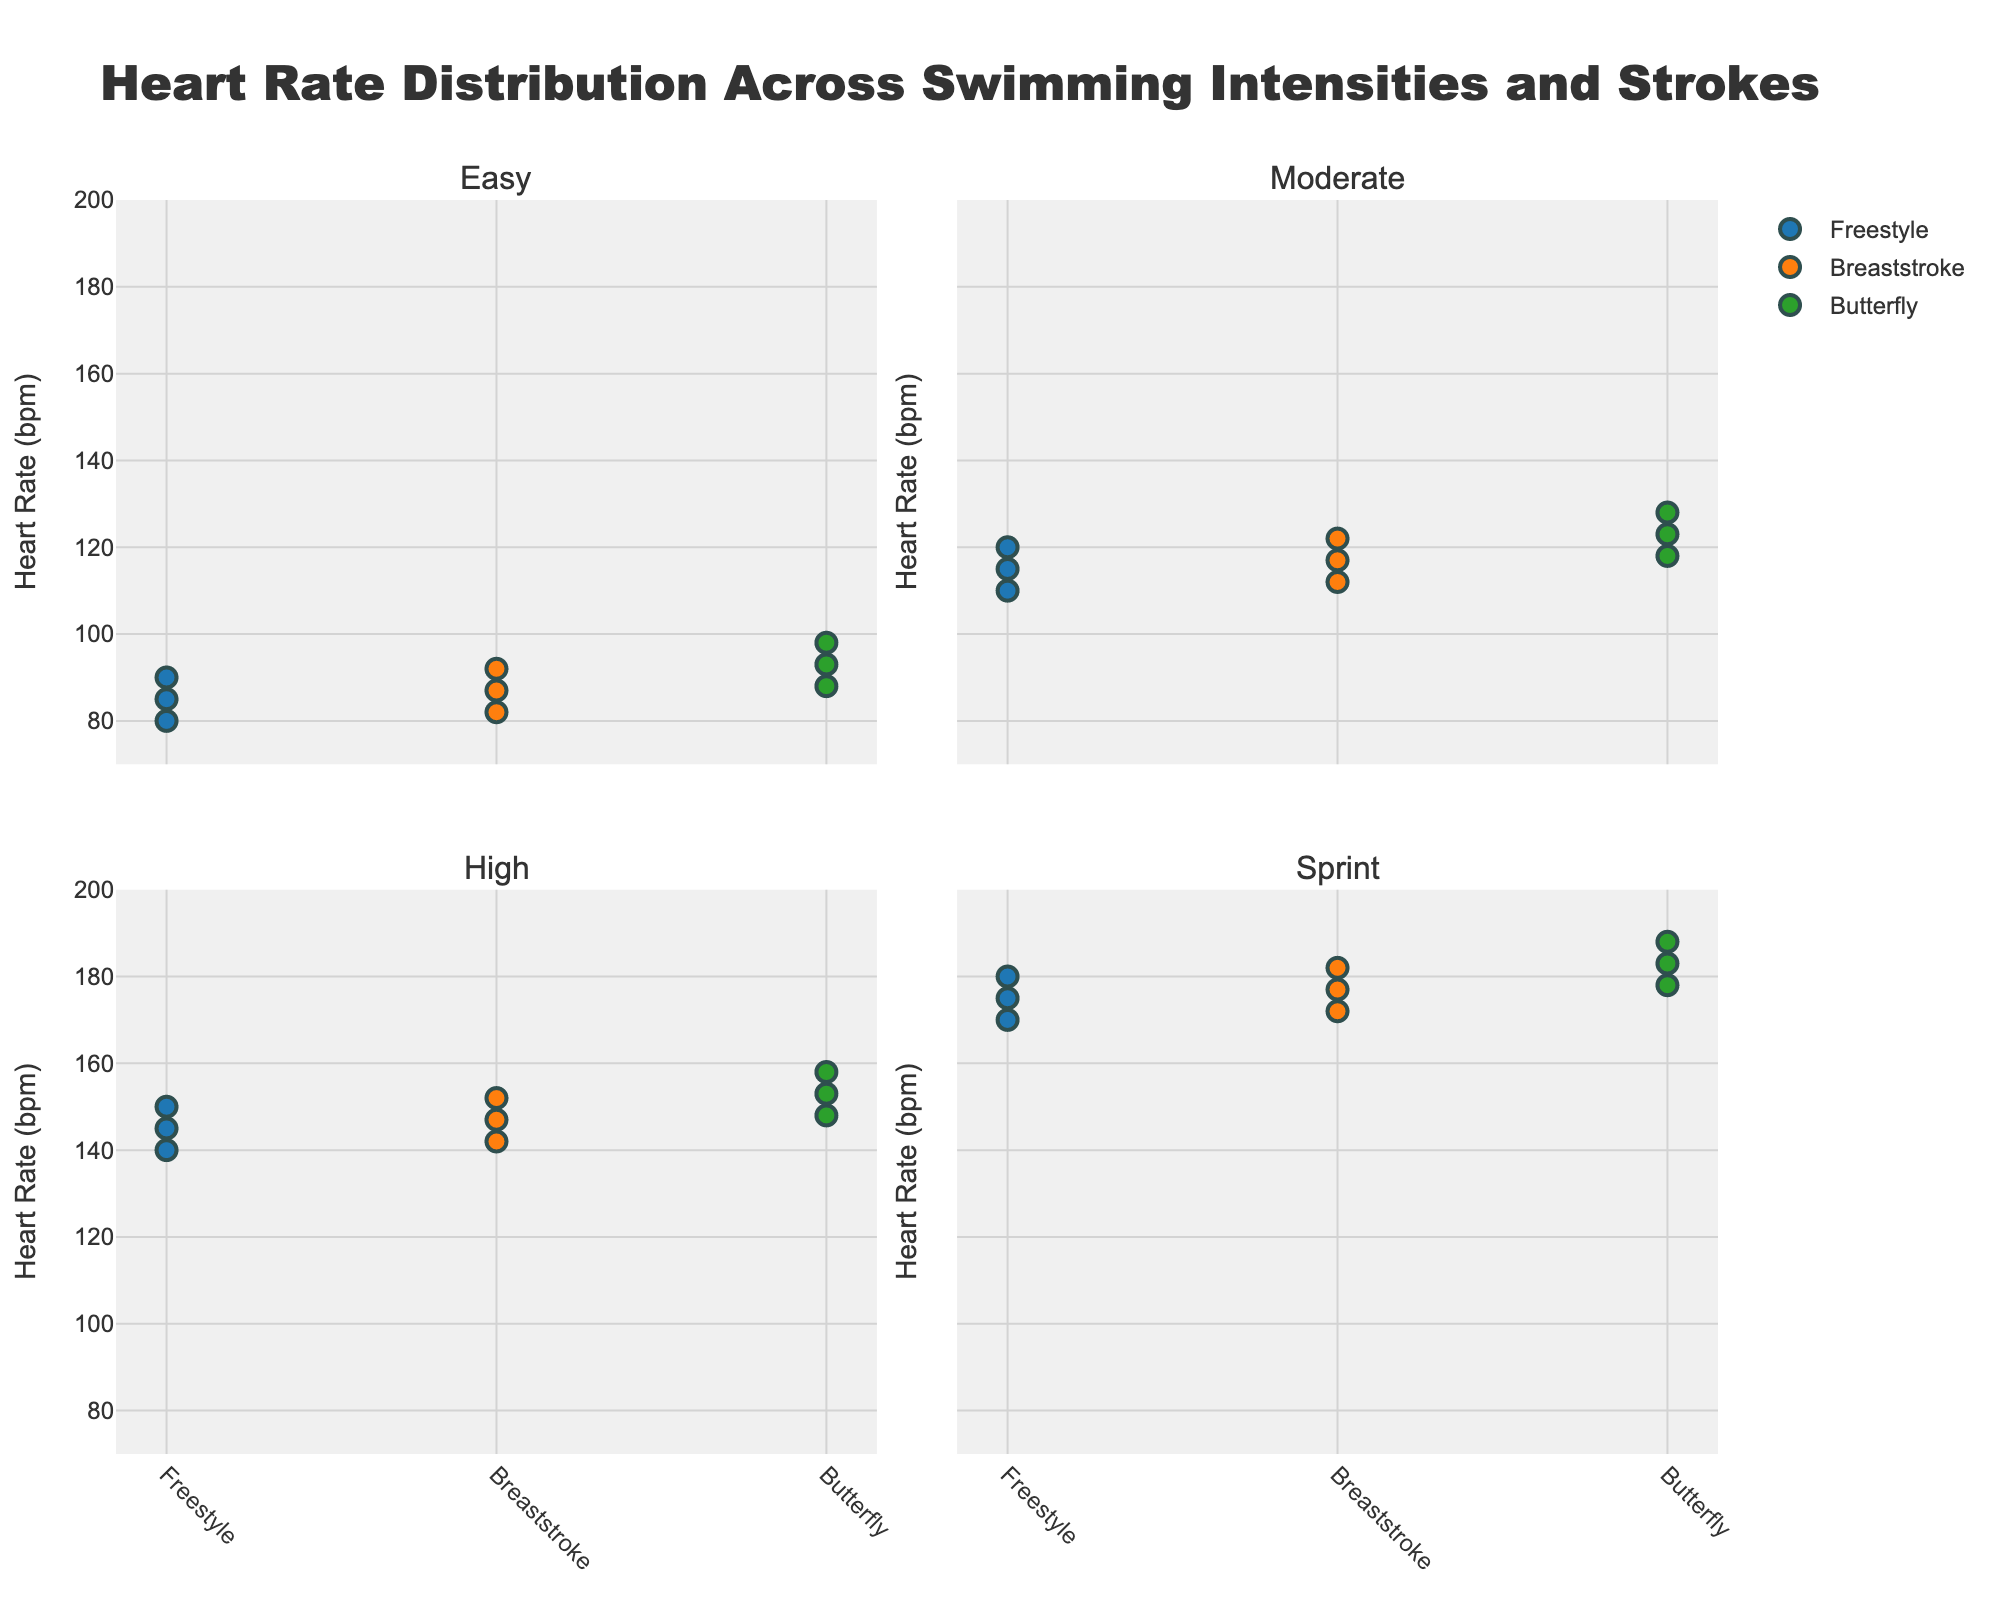What is the title of the figure? The title of the figure is located at the top and is labeled as "Heart Rate Distribution Across Swimming Intensities and Strokes".
Answer: Heart Rate Distribution Across Swimming Intensities and Strokes What are the axes labels in the figure? By examining the figure, the Y-axis is labeled "Heart Rate (bpm)" and the X-axes likely represent different strokes (Freestyle, Breaststroke, Butterfly) due to data segregation.
Answer: Heart Rate (bpm) and Stroke categories Which intensity shows the highest heart rate for the Butterfly stroke? Looking at the subplots, the highest heart rate for Butterfly stroke is under the "Sprint" intensity. The data point is at 188 bpm.
Answer: Sprint How many data points are present for the Freestyle stroke in the "Moderate" intensity subplot? In the plot for "Moderate" intensity, there are three data points for the Freestyle stroke: 110 bpm, 115 bpm, and 120 bpm.
Answer: 3 What is the range of heart rates for the Breaststroke stroke in the "High" intensity subplot? In the "High" intensity subplot, the heart rates for Breaststroke are 142 bpm, 147 bpm, and 152 bpm. The range is calculated by subtracting the minimum from the maximum: 152 - 142 = 10 bpm.
Answer: 10 bpm What's the average heart rate for the Freestyle stroke in the "Sprint" intensity? By summing up the heart rates for Freestyle in "Sprint" intensity (170, 175, 180) and dividing by the number of data points (3), the average heart rate is (170 + 175 + 180) / 3 = 525 / 3 = 175 bpm
Answer: 175 bpm Which stroke has the lowest heart rate in the "Easy" intensity subplot? In the "Easy" intensity subplot, the lowest heart rate is 80 bpm, which belongs to the Freestyle stroke.
Answer: Freestyle Compare the highest heart rates of Butterfly strokes between "Moderate" and "High" intensities, and identify which is greater. In "Moderate" intensity, the highest heart rate for Butterfly is 128 bpm. In "High" intensity, the highest heart rate for Butterfly is 158 bpm. Therefore, 158 bpm is greater than 128 bpm.
Answer: High intensity In which intensity does the Breaststroke stroke have the widest range of heart rates? For each intensity, determine the range (max - min) for Breaststroke: "Easy" (92-82 = 10 bpm), "Moderate" (122-112 = 10 bpm), "High" (152-142 = 10 bpm), "Sprint" (182-172 = 10 bpm). All intensities have the same range of 10 bpm for Breaststroke.
Answer: All intensities Which stroke has the most consistent heart rate range across all intensities? Checking the range consistency for each stroke, Freestyle: (10, 10, 10, 10) bpm, Breaststroke: (10, 10, 10, 10) bpm, Butterfly: (10, 10, 10, 10) bpm. All strokes have consistent heart rate ranges of 10 bpm across all intensities.
Answer: All strokes 